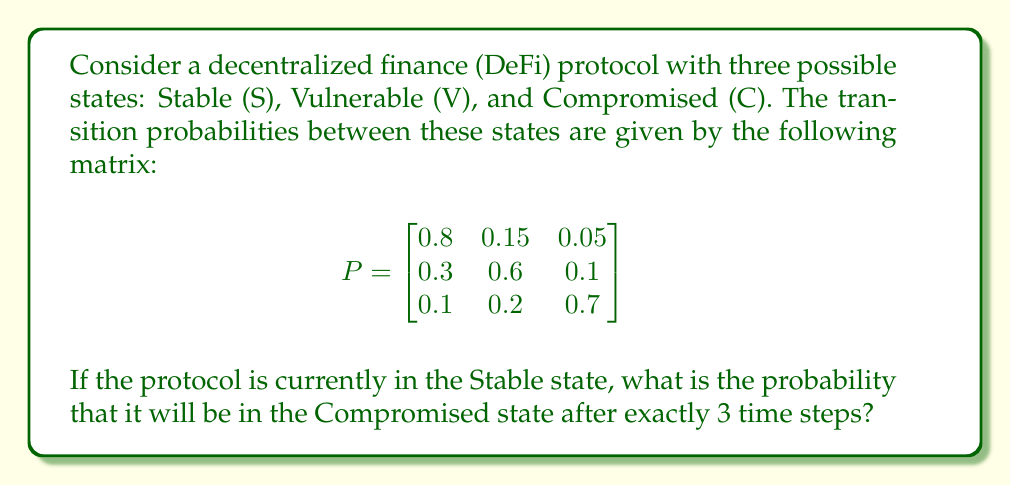Provide a solution to this math problem. To solve this problem, we need to use the Markov chain analysis and matrix multiplication. Let's proceed step-by-step:

1) The initial state vector is $\mathbf{v}_0 = \begin{bmatrix} 1 & 0 & 0 \end{bmatrix}$, as the protocol starts in the Stable state.

2) To find the state after 3 time steps, we need to multiply the initial state vector by the transition matrix raised to the power of 3:

   $\mathbf{v}_3 = \mathbf{v}_0 \cdot P^3$

3) Let's calculate $P^3$:
   
   $P^2 = P \cdot P = \begin{bmatrix}
   0.67 & 0.24 & 0.09 \\
   0.39 & 0.456 & 0.154 \\
   0.22 & 0.29 & 0.49
   \end{bmatrix}$

   $P^3 = P^2 \cdot P = \begin{bmatrix}
   0.581 & 0.2865 & 0.1325 \\
   0.417 & 0.3909 & 0.1921 \\
   0.295 & 0.3355 & 0.3695
   \end{bmatrix}$

4) Now, we multiply the initial state vector by $P^3$:

   $\mathbf{v}_3 = \begin{bmatrix} 1 & 0 & 0 \end{bmatrix} \cdot \begin{bmatrix}
   0.581 & 0.2865 & 0.1325 \\
   0.417 & 0.3909 & 0.1921 \\
   0.295 & 0.3355 & 0.3695
   \end{bmatrix} = \begin{bmatrix} 0.581 & 0.2865 & 0.1325 \end{bmatrix}$

5) The probability of being in the Compromised state (the third element of the resulting vector) after 3 time steps is 0.1325 or 13.25%.
Answer: 0.1325 